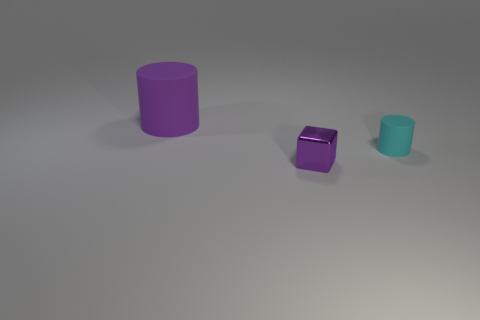Add 2 large rubber things. How many objects exist? 5 Subtract all cylinders. How many objects are left? 1 Add 2 purple matte things. How many purple matte things exist? 3 Subtract 0 green cubes. How many objects are left? 3 Subtract all large cylinders. Subtract all small things. How many objects are left? 0 Add 2 rubber cylinders. How many rubber cylinders are left? 4 